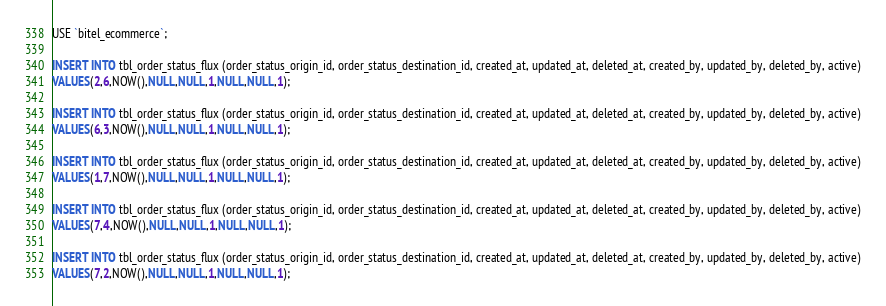<code> <loc_0><loc_0><loc_500><loc_500><_SQL_>USE `bitel_ecommerce`;

INSERT INTO tbl_order_status_flux (order_status_origin_id, order_status_destination_id, created_at, updated_at, deleted_at, created_by, updated_by, deleted_by, active)
VALUES(2,6,NOW(),NULL,NULL,1,NULL,NULL,1);

INSERT INTO tbl_order_status_flux (order_status_origin_id, order_status_destination_id, created_at, updated_at, deleted_at, created_by, updated_by, deleted_by, active)
VALUES(6,3,NOW(),NULL,NULL,1,NULL,NULL,1);

INSERT INTO tbl_order_status_flux (order_status_origin_id, order_status_destination_id, created_at, updated_at, deleted_at, created_by, updated_by, deleted_by, active)
VALUES(1,7,NOW(),NULL,NULL,1,NULL,NULL,1);

INSERT INTO tbl_order_status_flux (order_status_origin_id, order_status_destination_id, created_at, updated_at, deleted_at, created_by, updated_by, deleted_by, active)
VALUES(7,4,NOW(),NULL,NULL,1,NULL,NULL,1);

INSERT INTO tbl_order_status_flux (order_status_origin_id, order_status_destination_id, created_at, updated_at, deleted_at, created_by, updated_by, deleted_by, active)
VALUES(7,2,NOW(),NULL,NULL,1,NULL,NULL,1);
</code> 